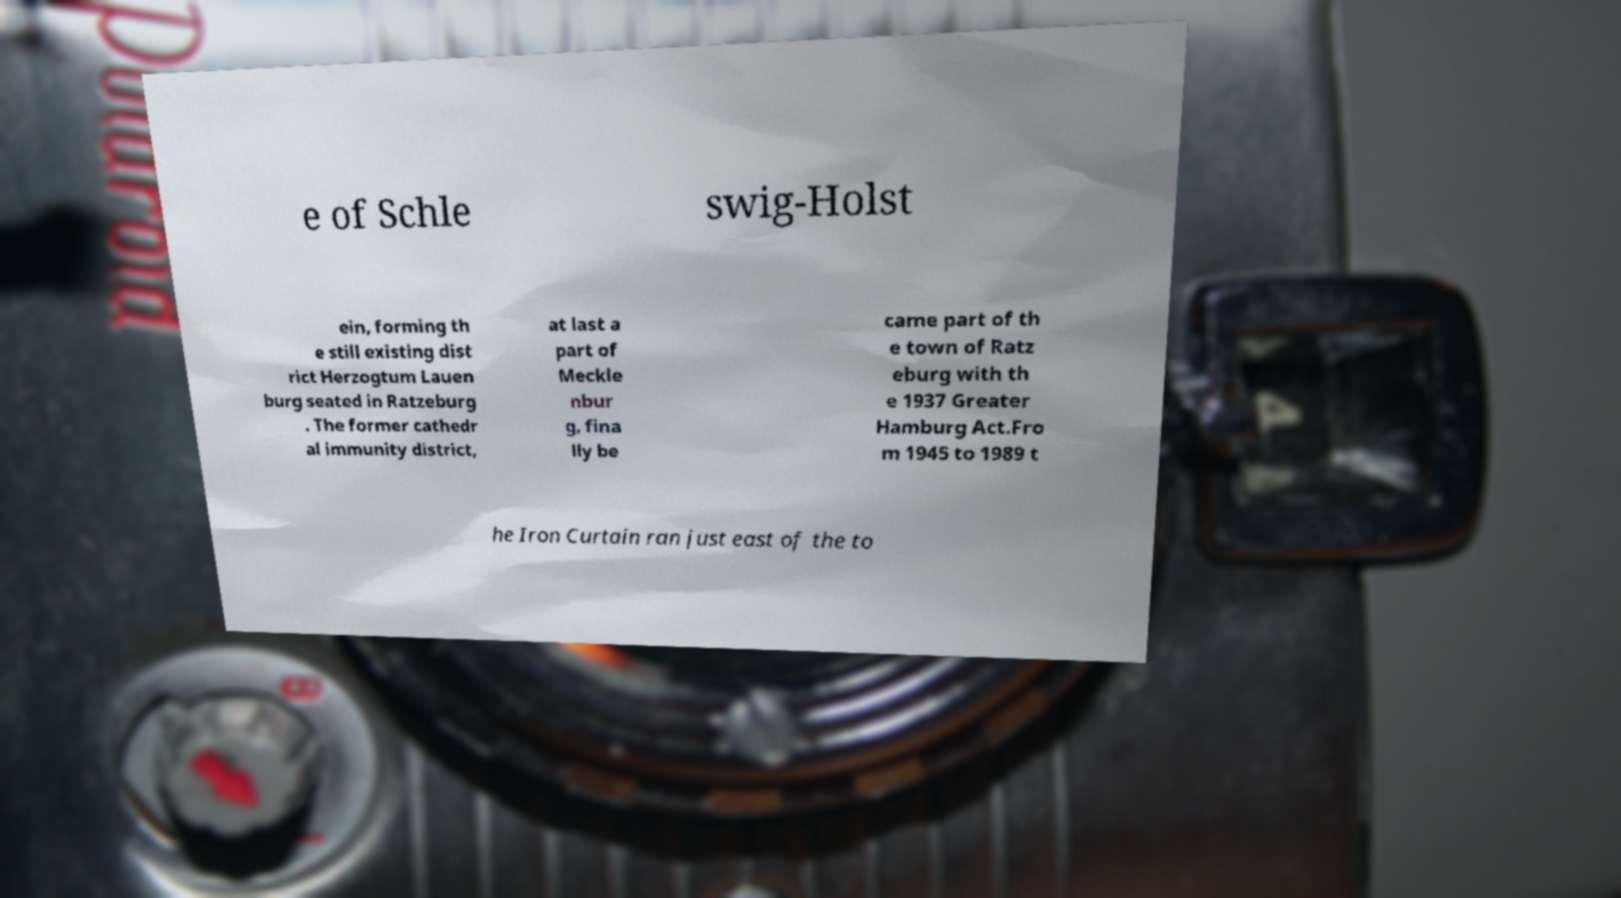Could you extract and type out the text from this image? e of Schle swig-Holst ein, forming th e still existing dist rict Herzogtum Lauen burg seated in Ratzeburg . The former cathedr al immunity district, at last a part of Meckle nbur g, fina lly be came part of th e town of Ratz eburg with th e 1937 Greater Hamburg Act.Fro m 1945 to 1989 t he Iron Curtain ran just east of the to 